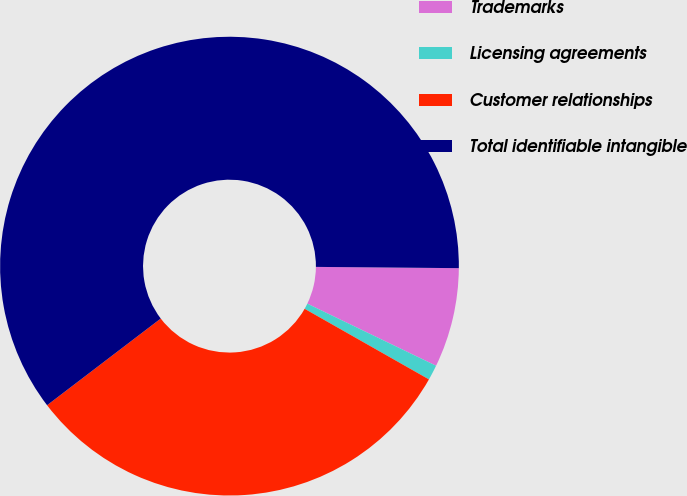<chart> <loc_0><loc_0><loc_500><loc_500><pie_chart><fcel>Trademarks<fcel>Licensing agreements<fcel>Customer relationships<fcel>Total identifiable intangible<nl><fcel>7.01%<fcel>1.07%<fcel>31.41%<fcel>60.51%<nl></chart> 